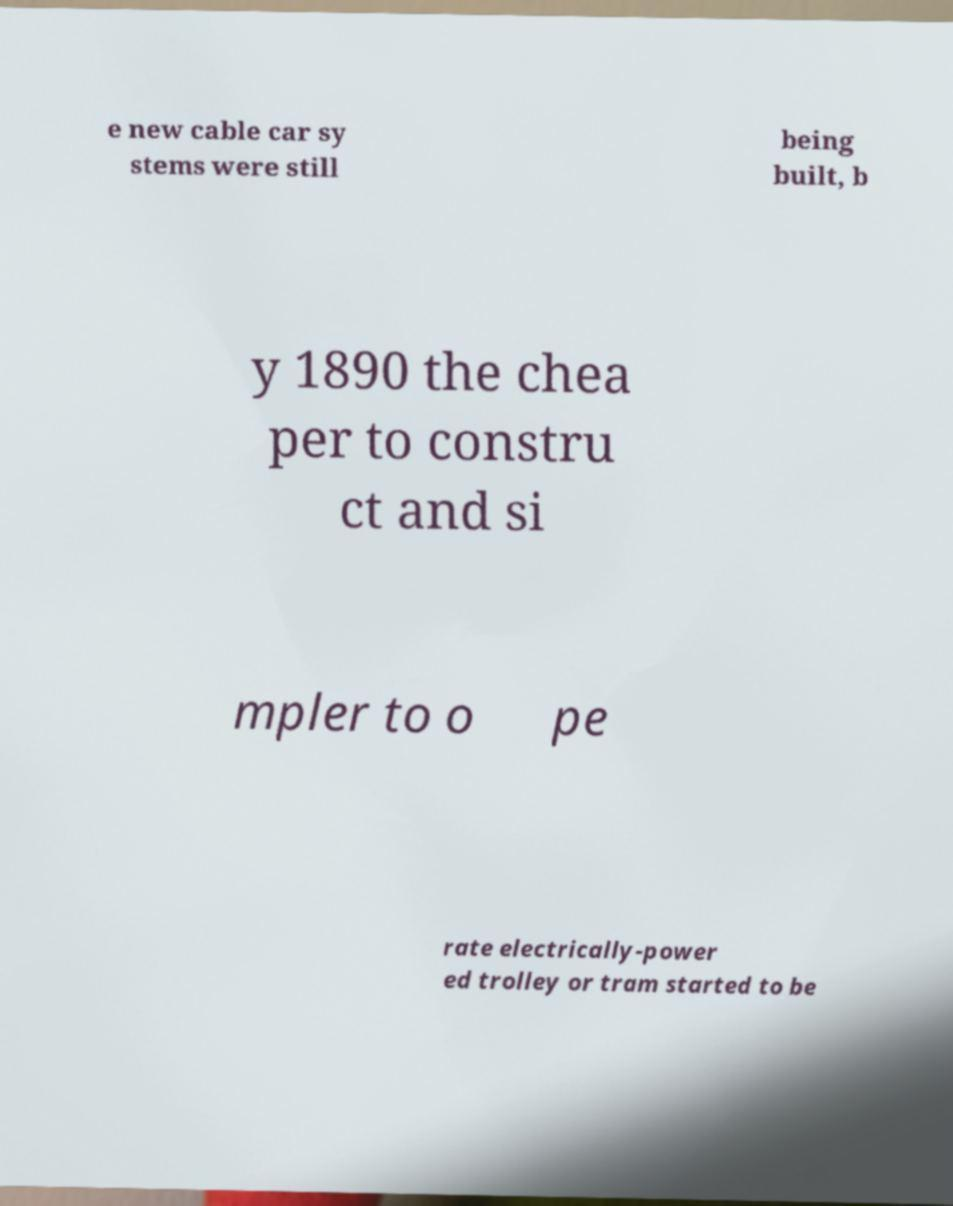Can you accurately transcribe the text from the provided image for me? e new cable car sy stems were still being built, b y 1890 the chea per to constru ct and si mpler to o pe rate electrically-power ed trolley or tram started to be 